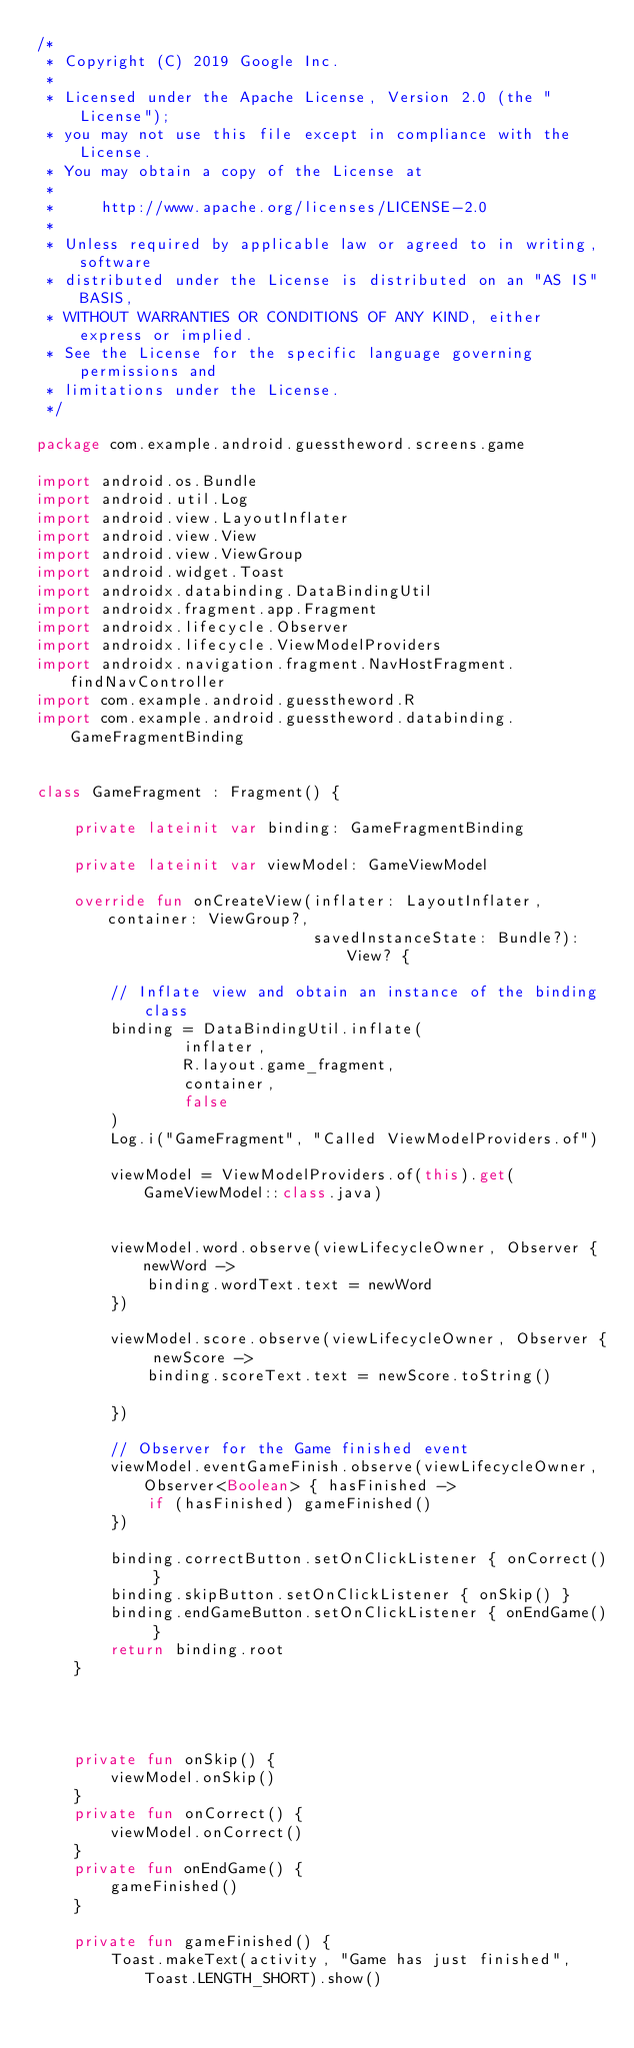Convert code to text. <code><loc_0><loc_0><loc_500><loc_500><_Kotlin_>/*
 * Copyright (C) 2019 Google Inc.
 *
 * Licensed under the Apache License, Version 2.0 (the "License");
 * you may not use this file except in compliance with the License.
 * You may obtain a copy of the License at
 *
 *     http://www.apache.org/licenses/LICENSE-2.0
 *
 * Unless required by applicable law or agreed to in writing, software
 * distributed under the License is distributed on an "AS IS" BASIS,
 * WITHOUT WARRANTIES OR CONDITIONS OF ANY KIND, either express or implied.
 * See the License for the specific language governing permissions and
 * limitations under the License.
 */

package com.example.android.guesstheword.screens.game

import android.os.Bundle
import android.util.Log
import android.view.LayoutInflater
import android.view.View
import android.view.ViewGroup
import android.widget.Toast
import androidx.databinding.DataBindingUtil
import androidx.fragment.app.Fragment
import androidx.lifecycle.Observer
import androidx.lifecycle.ViewModelProviders
import androidx.navigation.fragment.NavHostFragment.findNavController
import com.example.android.guesstheword.R
import com.example.android.guesstheword.databinding.GameFragmentBinding


class GameFragment : Fragment() {

    private lateinit var binding: GameFragmentBinding

    private lateinit var viewModel: GameViewModel

    override fun onCreateView(inflater: LayoutInflater, container: ViewGroup?,
                              savedInstanceState: Bundle?): View? {

        // Inflate view and obtain an instance of the binding class
        binding = DataBindingUtil.inflate(
                inflater,
                R.layout.game_fragment,
                container,
                false
        )
        Log.i("GameFragment", "Called ViewModelProviders.of")

        viewModel = ViewModelProviders.of(this).get(GameViewModel::class.java)


        viewModel.word.observe(viewLifecycleOwner, Observer { newWord ->
            binding.wordText.text = newWord
        })

        viewModel.score.observe(viewLifecycleOwner, Observer { newScore ->
            binding.scoreText.text = newScore.toString()

        })

        // Observer for the Game finished event
        viewModel.eventGameFinish.observe(viewLifecycleOwner, Observer<Boolean> { hasFinished ->
            if (hasFinished) gameFinished()
        })

        binding.correctButton.setOnClickListener { onCorrect() }
        binding.skipButton.setOnClickListener { onSkip() }
        binding.endGameButton.setOnClickListener { onEndGame() }
        return binding.root
    }




    private fun onSkip() {
        viewModel.onSkip()
    }
    private fun onCorrect() {
        viewModel.onCorrect()
    }
    private fun onEndGame() {
        gameFinished()
    }

    private fun gameFinished() {
        Toast.makeText(activity, "Game has just finished", Toast.LENGTH_SHORT).show()</code> 